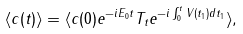Convert formula to latex. <formula><loc_0><loc_0><loc_500><loc_500>\langle c ( t ) \rangle = \langle c ( 0 ) e ^ { - i E _ { 0 } t } T _ { t } e ^ { - i \int _ { 0 } ^ { t } V ( t _ { 1 } ) d t _ { 1 } } \rangle ,</formula> 